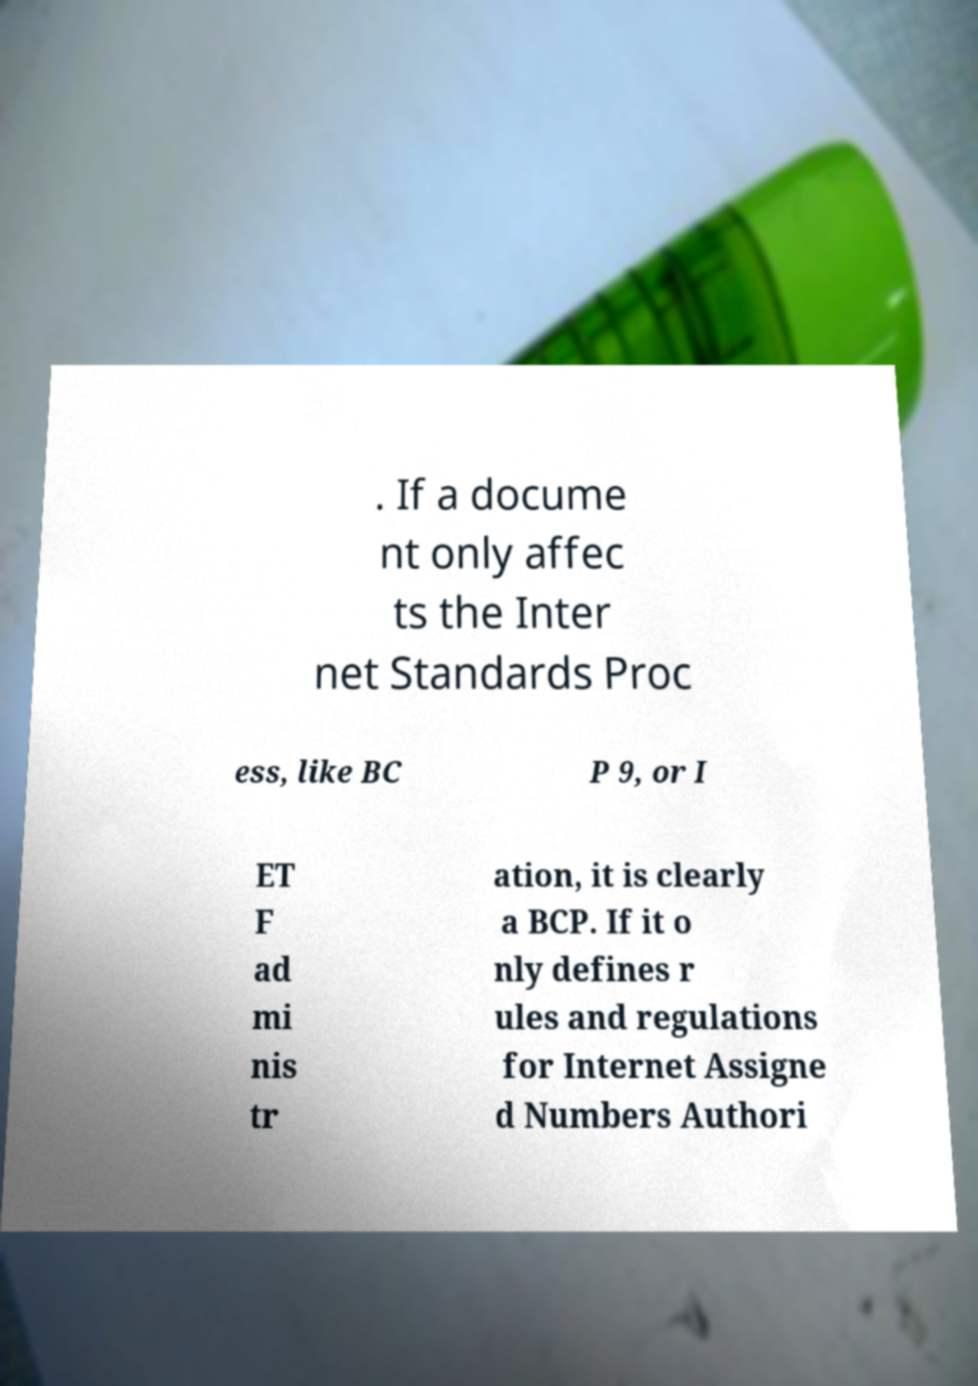Can you accurately transcribe the text from the provided image for me? . If a docume nt only affec ts the Inter net Standards Proc ess, like BC P 9, or I ET F ad mi nis tr ation, it is clearly a BCP. If it o nly defines r ules and regulations for Internet Assigne d Numbers Authori 